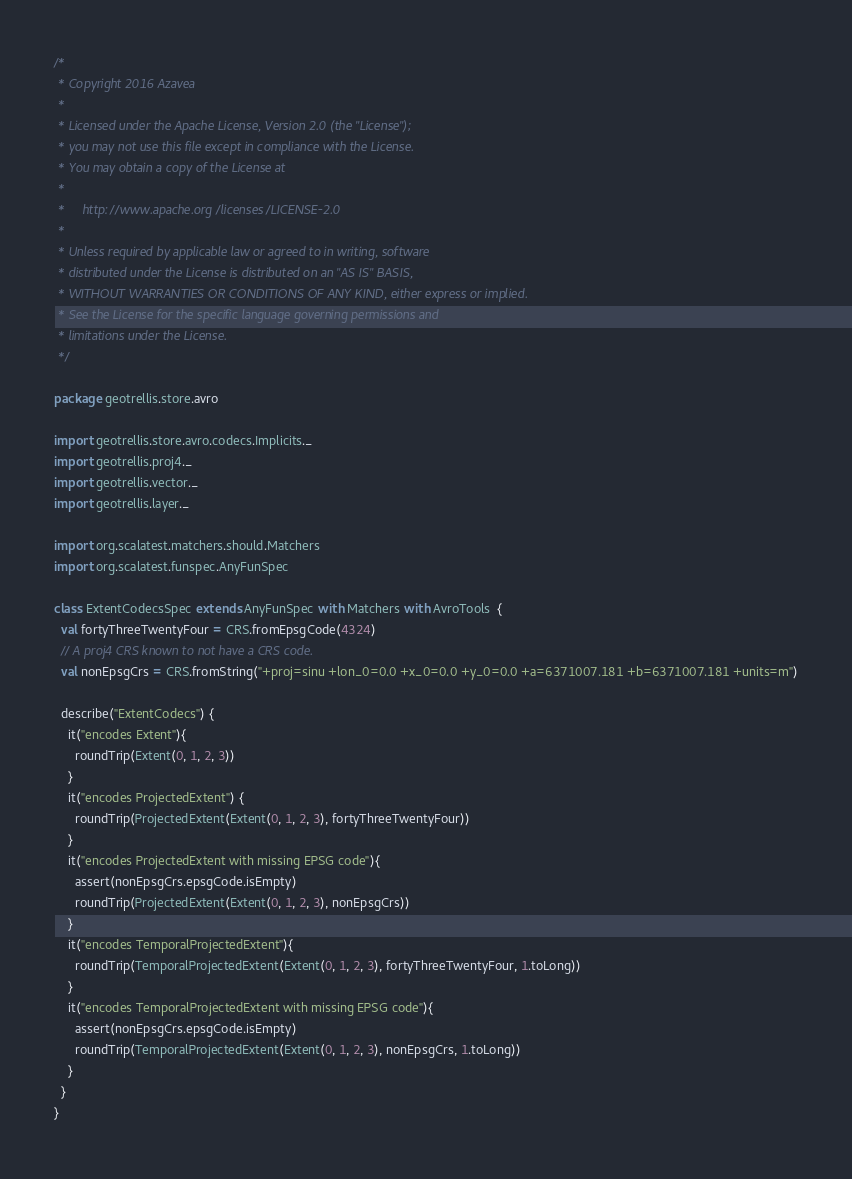<code> <loc_0><loc_0><loc_500><loc_500><_Scala_>/*
 * Copyright 2016 Azavea
 *
 * Licensed under the Apache License, Version 2.0 (the "License");
 * you may not use this file except in compliance with the License.
 * You may obtain a copy of the License at
 *
 *     http://www.apache.org/licenses/LICENSE-2.0
 *
 * Unless required by applicable law or agreed to in writing, software
 * distributed under the License is distributed on an "AS IS" BASIS,
 * WITHOUT WARRANTIES OR CONDITIONS OF ANY KIND, either express or implied.
 * See the License for the specific language governing permissions and
 * limitations under the License.
 */

package geotrellis.store.avro

import geotrellis.store.avro.codecs.Implicits._
import geotrellis.proj4._
import geotrellis.vector._
import geotrellis.layer._

import org.scalatest.matchers.should.Matchers
import org.scalatest.funspec.AnyFunSpec

class ExtentCodecsSpec extends AnyFunSpec with Matchers with AvroTools  {
  val fortyThreeTwentyFour = CRS.fromEpsgCode(4324)
  // A proj4 CRS known to not have a CRS code.
  val nonEpsgCrs = CRS.fromString("+proj=sinu +lon_0=0.0 +x_0=0.0 +y_0=0.0 +a=6371007.181 +b=6371007.181 +units=m")

  describe("ExtentCodecs") {
    it("encodes Extent"){
      roundTrip(Extent(0, 1, 2, 3))
    }
    it("encodes ProjectedExtent") {
      roundTrip(ProjectedExtent(Extent(0, 1, 2, 3), fortyThreeTwentyFour))
    }
    it("encodes ProjectedExtent with missing EPSG code"){
      assert(nonEpsgCrs.epsgCode.isEmpty)
      roundTrip(ProjectedExtent(Extent(0, 1, 2, 3), nonEpsgCrs))
    }
    it("encodes TemporalProjectedExtent"){
      roundTrip(TemporalProjectedExtent(Extent(0, 1, 2, 3), fortyThreeTwentyFour, 1.toLong))
    }
    it("encodes TemporalProjectedExtent with missing EPSG code"){
      assert(nonEpsgCrs.epsgCode.isEmpty)
      roundTrip(TemporalProjectedExtent(Extent(0, 1, 2, 3), nonEpsgCrs, 1.toLong))
    }
  }
}
</code> 